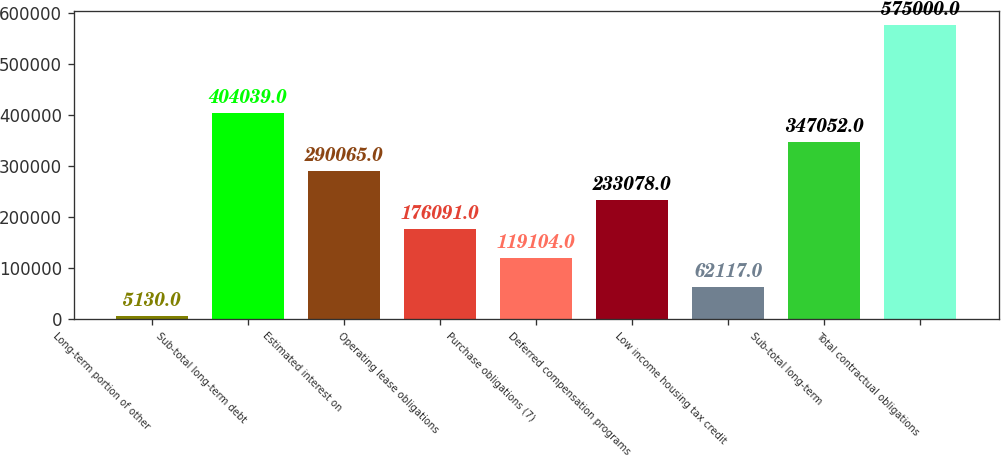<chart> <loc_0><loc_0><loc_500><loc_500><bar_chart><fcel>Long-term portion of other<fcel>Sub-total long-term debt<fcel>Estimated interest on<fcel>Operating lease obligations<fcel>Purchase obligations (7)<fcel>Deferred compensation programs<fcel>Low income housing tax credit<fcel>Sub-total long-term<fcel>Total contractual obligations<nl><fcel>5130<fcel>404039<fcel>290065<fcel>176091<fcel>119104<fcel>233078<fcel>62117<fcel>347052<fcel>575000<nl></chart> 